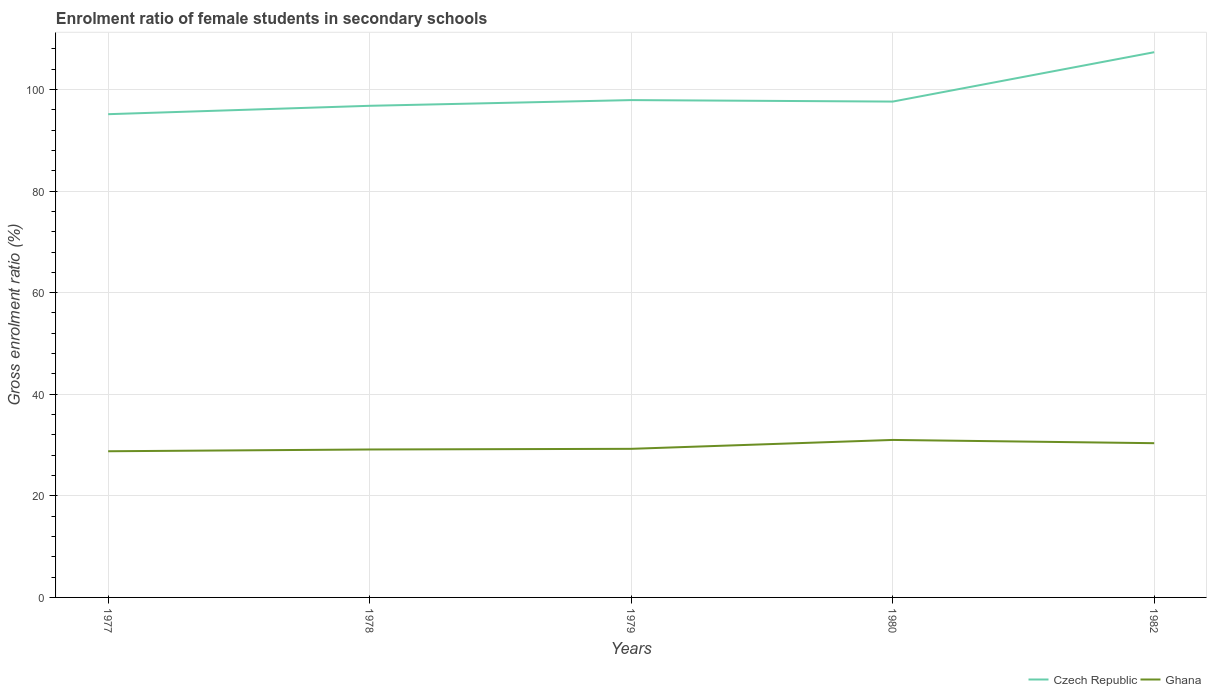Is the number of lines equal to the number of legend labels?
Keep it short and to the point. Yes. Across all years, what is the maximum enrolment ratio of female students in secondary schools in Ghana?
Ensure brevity in your answer.  28.78. In which year was the enrolment ratio of female students in secondary schools in Czech Republic maximum?
Ensure brevity in your answer.  1977. What is the total enrolment ratio of female students in secondary schools in Czech Republic in the graph?
Offer a very short reply. -1.65. What is the difference between the highest and the second highest enrolment ratio of female students in secondary schools in Ghana?
Give a very brief answer. 2.23. What is the difference between the highest and the lowest enrolment ratio of female students in secondary schools in Czech Republic?
Your response must be concise. 1. Is the enrolment ratio of female students in secondary schools in Ghana strictly greater than the enrolment ratio of female students in secondary schools in Czech Republic over the years?
Provide a succinct answer. Yes. How many years are there in the graph?
Ensure brevity in your answer.  5. Are the values on the major ticks of Y-axis written in scientific E-notation?
Make the answer very short. No. Does the graph contain any zero values?
Offer a terse response. No. Where does the legend appear in the graph?
Ensure brevity in your answer.  Bottom right. What is the title of the graph?
Provide a succinct answer. Enrolment ratio of female students in secondary schools. Does "Togo" appear as one of the legend labels in the graph?
Keep it short and to the point. No. What is the label or title of the X-axis?
Keep it short and to the point. Years. What is the label or title of the Y-axis?
Your answer should be very brief. Gross enrolment ratio (%). What is the Gross enrolment ratio (%) in Czech Republic in 1977?
Ensure brevity in your answer.  95.14. What is the Gross enrolment ratio (%) of Ghana in 1977?
Your answer should be compact. 28.78. What is the Gross enrolment ratio (%) of Czech Republic in 1978?
Provide a short and direct response. 96.79. What is the Gross enrolment ratio (%) of Ghana in 1978?
Offer a terse response. 29.13. What is the Gross enrolment ratio (%) in Czech Republic in 1979?
Provide a short and direct response. 97.92. What is the Gross enrolment ratio (%) of Ghana in 1979?
Keep it short and to the point. 29.26. What is the Gross enrolment ratio (%) in Czech Republic in 1980?
Keep it short and to the point. 97.62. What is the Gross enrolment ratio (%) of Ghana in 1980?
Ensure brevity in your answer.  31.01. What is the Gross enrolment ratio (%) of Czech Republic in 1982?
Ensure brevity in your answer.  107.35. What is the Gross enrolment ratio (%) in Ghana in 1982?
Offer a very short reply. 30.37. Across all years, what is the maximum Gross enrolment ratio (%) in Czech Republic?
Your response must be concise. 107.35. Across all years, what is the maximum Gross enrolment ratio (%) in Ghana?
Your answer should be compact. 31.01. Across all years, what is the minimum Gross enrolment ratio (%) in Czech Republic?
Make the answer very short. 95.14. Across all years, what is the minimum Gross enrolment ratio (%) of Ghana?
Provide a short and direct response. 28.78. What is the total Gross enrolment ratio (%) in Czech Republic in the graph?
Ensure brevity in your answer.  494.83. What is the total Gross enrolment ratio (%) of Ghana in the graph?
Your answer should be very brief. 148.54. What is the difference between the Gross enrolment ratio (%) of Czech Republic in 1977 and that in 1978?
Provide a short and direct response. -1.65. What is the difference between the Gross enrolment ratio (%) in Ghana in 1977 and that in 1978?
Offer a very short reply. -0.35. What is the difference between the Gross enrolment ratio (%) of Czech Republic in 1977 and that in 1979?
Provide a short and direct response. -2.77. What is the difference between the Gross enrolment ratio (%) in Ghana in 1977 and that in 1979?
Your response must be concise. -0.48. What is the difference between the Gross enrolment ratio (%) in Czech Republic in 1977 and that in 1980?
Ensure brevity in your answer.  -2.48. What is the difference between the Gross enrolment ratio (%) of Ghana in 1977 and that in 1980?
Your answer should be compact. -2.23. What is the difference between the Gross enrolment ratio (%) of Czech Republic in 1977 and that in 1982?
Offer a terse response. -12.2. What is the difference between the Gross enrolment ratio (%) of Ghana in 1977 and that in 1982?
Keep it short and to the point. -1.59. What is the difference between the Gross enrolment ratio (%) in Czech Republic in 1978 and that in 1979?
Your answer should be compact. -1.13. What is the difference between the Gross enrolment ratio (%) in Ghana in 1978 and that in 1979?
Offer a very short reply. -0.13. What is the difference between the Gross enrolment ratio (%) in Czech Republic in 1978 and that in 1980?
Make the answer very short. -0.83. What is the difference between the Gross enrolment ratio (%) in Ghana in 1978 and that in 1980?
Keep it short and to the point. -1.88. What is the difference between the Gross enrolment ratio (%) of Czech Republic in 1978 and that in 1982?
Make the answer very short. -10.55. What is the difference between the Gross enrolment ratio (%) of Ghana in 1978 and that in 1982?
Your response must be concise. -1.24. What is the difference between the Gross enrolment ratio (%) of Czech Republic in 1979 and that in 1980?
Your answer should be compact. 0.29. What is the difference between the Gross enrolment ratio (%) in Ghana in 1979 and that in 1980?
Provide a short and direct response. -1.75. What is the difference between the Gross enrolment ratio (%) in Czech Republic in 1979 and that in 1982?
Give a very brief answer. -9.43. What is the difference between the Gross enrolment ratio (%) of Ghana in 1979 and that in 1982?
Provide a succinct answer. -1.11. What is the difference between the Gross enrolment ratio (%) in Czech Republic in 1980 and that in 1982?
Offer a terse response. -9.72. What is the difference between the Gross enrolment ratio (%) in Ghana in 1980 and that in 1982?
Your response must be concise. 0.64. What is the difference between the Gross enrolment ratio (%) in Czech Republic in 1977 and the Gross enrolment ratio (%) in Ghana in 1978?
Make the answer very short. 66.02. What is the difference between the Gross enrolment ratio (%) of Czech Republic in 1977 and the Gross enrolment ratio (%) of Ghana in 1979?
Provide a short and direct response. 65.89. What is the difference between the Gross enrolment ratio (%) of Czech Republic in 1977 and the Gross enrolment ratio (%) of Ghana in 1980?
Your answer should be compact. 64.14. What is the difference between the Gross enrolment ratio (%) in Czech Republic in 1977 and the Gross enrolment ratio (%) in Ghana in 1982?
Ensure brevity in your answer.  64.78. What is the difference between the Gross enrolment ratio (%) in Czech Republic in 1978 and the Gross enrolment ratio (%) in Ghana in 1979?
Keep it short and to the point. 67.54. What is the difference between the Gross enrolment ratio (%) of Czech Republic in 1978 and the Gross enrolment ratio (%) of Ghana in 1980?
Offer a very short reply. 65.79. What is the difference between the Gross enrolment ratio (%) of Czech Republic in 1978 and the Gross enrolment ratio (%) of Ghana in 1982?
Offer a very short reply. 66.43. What is the difference between the Gross enrolment ratio (%) of Czech Republic in 1979 and the Gross enrolment ratio (%) of Ghana in 1980?
Provide a succinct answer. 66.91. What is the difference between the Gross enrolment ratio (%) of Czech Republic in 1979 and the Gross enrolment ratio (%) of Ghana in 1982?
Ensure brevity in your answer.  67.55. What is the difference between the Gross enrolment ratio (%) of Czech Republic in 1980 and the Gross enrolment ratio (%) of Ghana in 1982?
Provide a short and direct response. 67.26. What is the average Gross enrolment ratio (%) in Czech Republic per year?
Ensure brevity in your answer.  98.97. What is the average Gross enrolment ratio (%) of Ghana per year?
Offer a very short reply. 29.71. In the year 1977, what is the difference between the Gross enrolment ratio (%) in Czech Republic and Gross enrolment ratio (%) in Ghana?
Provide a short and direct response. 66.36. In the year 1978, what is the difference between the Gross enrolment ratio (%) of Czech Republic and Gross enrolment ratio (%) of Ghana?
Keep it short and to the point. 67.67. In the year 1979, what is the difference between the Gross enrolment ratio (%) in Czech Republic and Gross enrolment ratio (%) in Ghana?
Offer a very short reply. 68.66. In the year 1980, what is the difference between the Gross enrolment ratio (%) in Czech Republic and Gross enrolment ratio (%) in Ghana?
Ensure brevity in your answer.  66.62. In the year 1982, what is the difference between the Gross enrolment ratio (%) in Czech Republic and Gross enrolment ratio (%) in Ghana?
Your answer should be very brief. 76.98. What is the ratio of the Gross enrolment ratio (%) of Czech Republic in 1977 to that in 1978?
Keep it short and to the point. 0.98. What is the ratio of the Gross enrolment ratio (%) in Ghana in 1977 to that in 1978?
Your answer should be compact. 0.99. What is the ratio of the Gross enrolment ratio (%) of Czech Republic in 1977 to that in 1979?
Keep it short and to the point. 0.97. What is the ratio of the Gross enrolment ratio (%) of Ghana in 1977 to that in 1979?
Provide a short and direct response. 0.98. What is the ratio of the Gross enrolment ratio (%) of Czech Republic in 1977 to that in 1980?
Keep it short and to the point. 0.97. What is the ratio of the Gross enrolment ratio (%) of Ghana in 1977 to that in 1980?
Ensure brevity in your answer.  0.93. What is the ratio of the Gross enrolment ratio (%) in Czech Republic in 1977 to that in 1982?
Your answer should be very brief. 0.89. What is the ratio of the Gross enrolment ratio (%) of Ghana in 1977 to that in 1982?
Your answer should be very brief. 0.95. What is the ratio of the Gross enrolment ratio (%) of Czech Republic in 1978 to that in 1979?
Provide a short and direct response. 0.99. What is the ratio of the Gross enrolment ratio (%) of Ghana in 1978 to that in 1979?
Provide a short and direct response. 1. What is the ratio of the Gross enrolment ratio (%) in Ghana in 1978 to that in 1980?
Provide a succinct answer. 0.94. What is the ratio of the Gross enrolment ratio (%) in Czech Republic in 1978 to that in 1982?
Ensure brevity in your answer.  0.9. What is the ratio of the Gross enrolment ratio (%) in Ghana in 1978 to that in 1982?
Make the answer very short. 0.96. What is the ratio of the Gross enrolment ratio (%) of Czech Republic in 1979 to that in 1980?
Offer a very short reply. 1. What is the ratio of the Gross enrolment ratio (%) in Ghana in 1979 to that in 1980?
Your response must be concise. 0.94. What is the ratio of the Gross enrolment ratio (%) of Czech Republic in 1979 to that in 1982?
Keep it short and to the point. 0.91. What is the ratio of the Gross enrolment ratio (%) of Ghana in 1979 to that in 1982?
Give a very brief answer. 0.96. What is the ratio of the Gross enrolment ratio (%) of Czech Republic in 1980 to that in 1982?
Ensure brevity in your answer.  0.91. What is the ratio of the Gross enrolment ratio (%) of Ghana in 1980 to that in 1982?
Offer a very short reply. 1.02. What is the difference between the highest and the second highest Gross enrolment ratio (%) in Czech Republic?
Offer a very short reply. 9.43. What is the difference between the highest and the second highest Gross enrolment ratio (%) in Ghana?
Your response must be concise. 0.64. What is the difference between the highest and the lowest Gross enrolment ratio (%) of Czech Republic?
Give a very brief answer. 12.2. What is the difference between the highest and the lowest Gross enrolment ratio (%) of Ghana?
Keep it short and to the point. 2.23. 